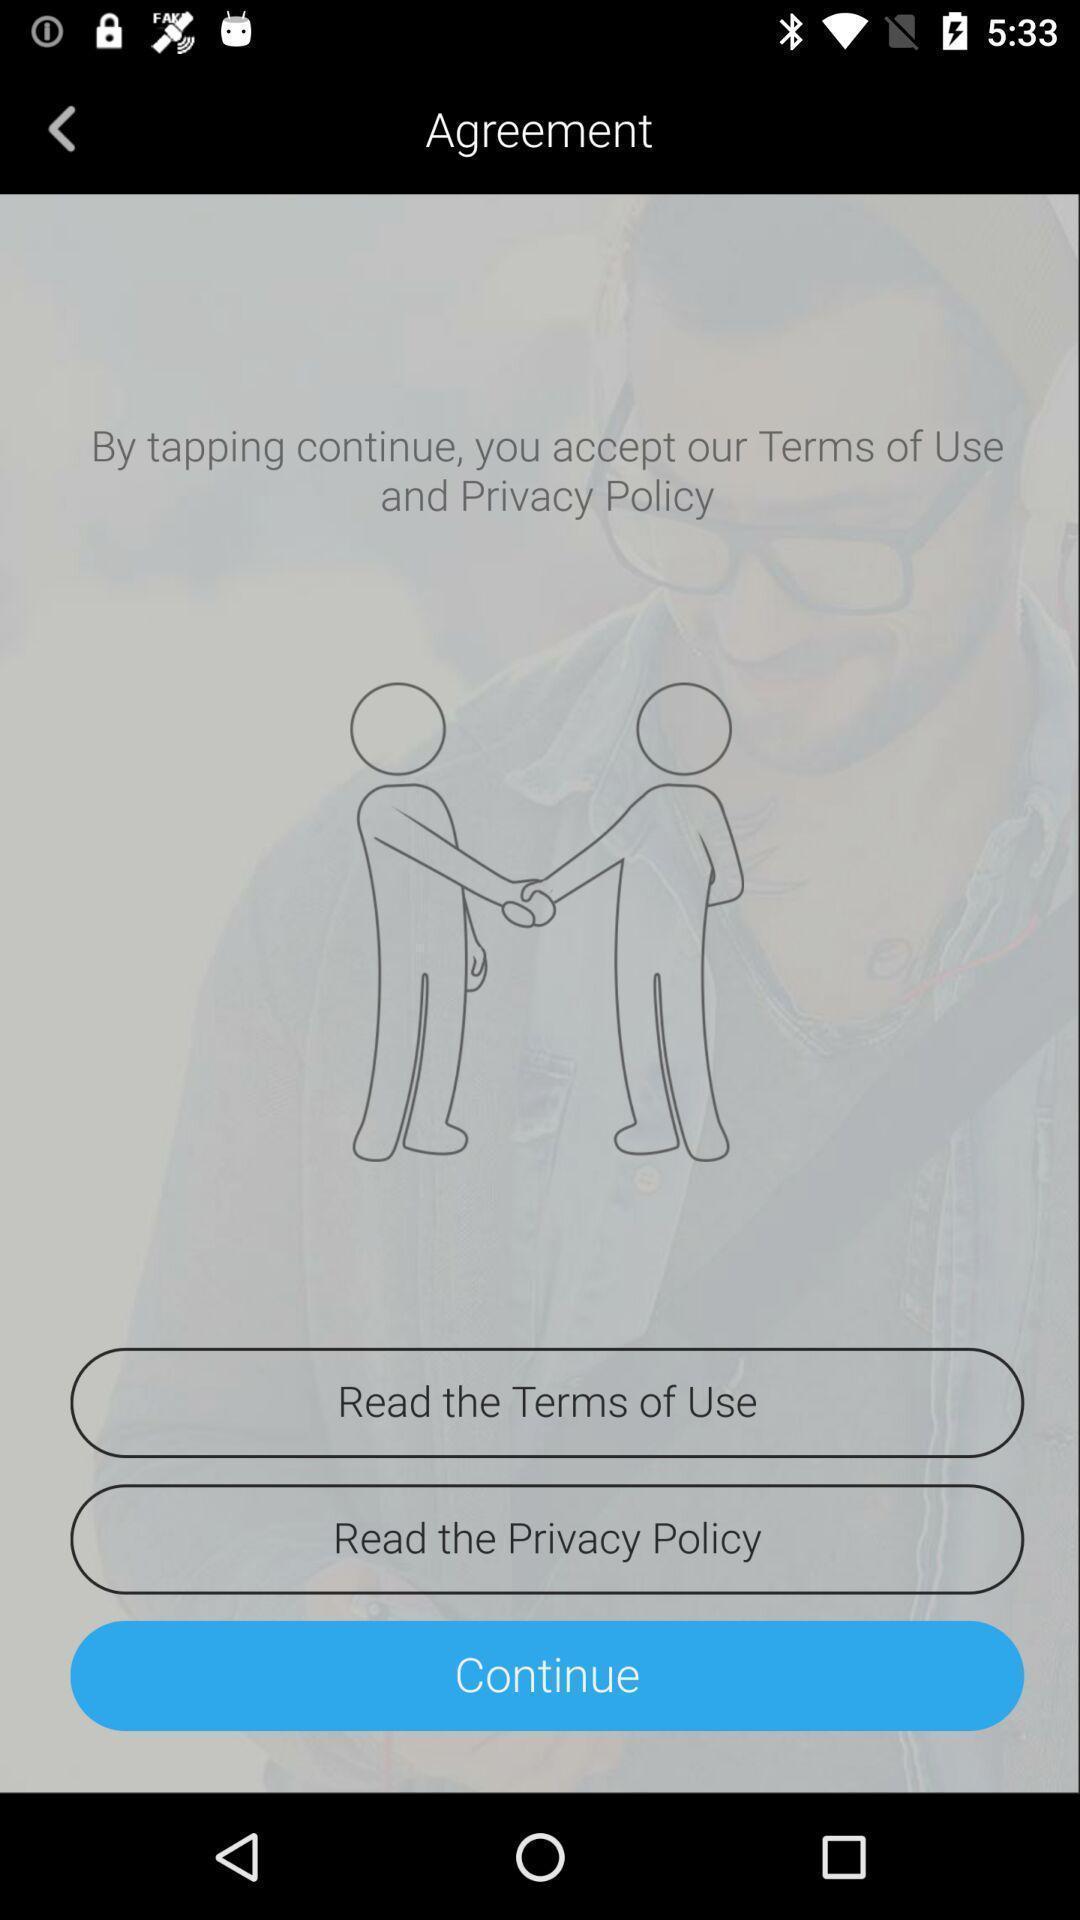Give me a narrative description of this picture. Page showing continue option. 